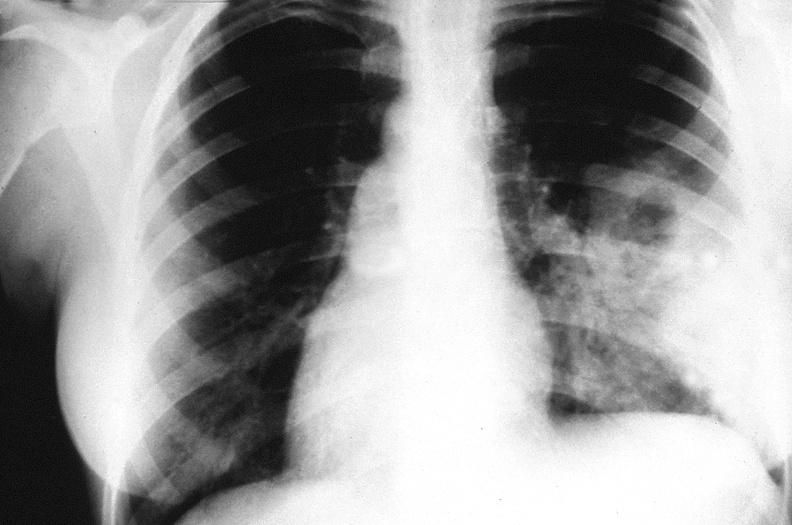does purulent sinusitis show chest x-ray, cryptococcal pneumonia?
Answer the question using a single word or phrase. No 